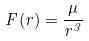<formula> <loc_0><loc_0><loc_500><loc_500>F ( r ) = \frac { \mu } { r ^ { 3 } }</formula> 